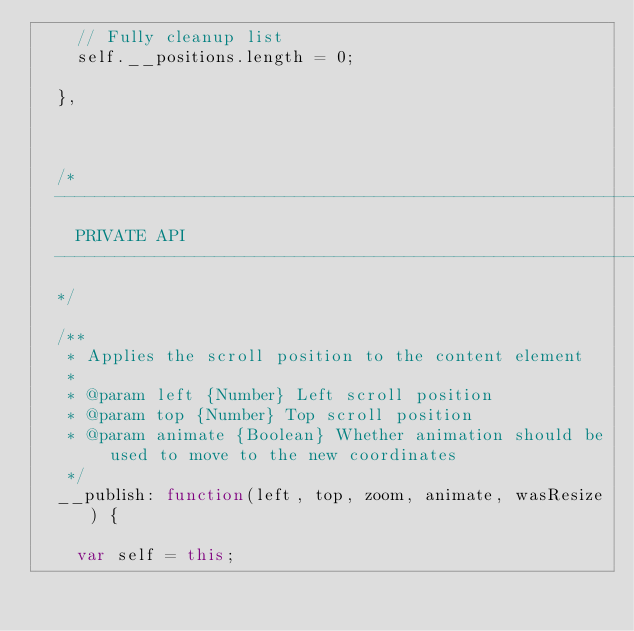<code> <loc_0><loc_0><loc_500><loc_500><_JavaScript_>    // Fully cleanup list
    self.__positions.length = 0;

  },



  /*
  ---------------------------------------------------------------------------
    PRIVATE API
  ---------------------------------------------------------------------------
  */

  /**
   * Applies the scroll position to the content element
   *
   * @param left {Number} Left scroll position
   * @param top {Number} Top scroll position
   * @param animate {Boolean} Whether animation should be used to move to the new coordinates
   */
  __publish: function(left, top, zoom, animate, wasResize) {

    var self = this;
</code> 